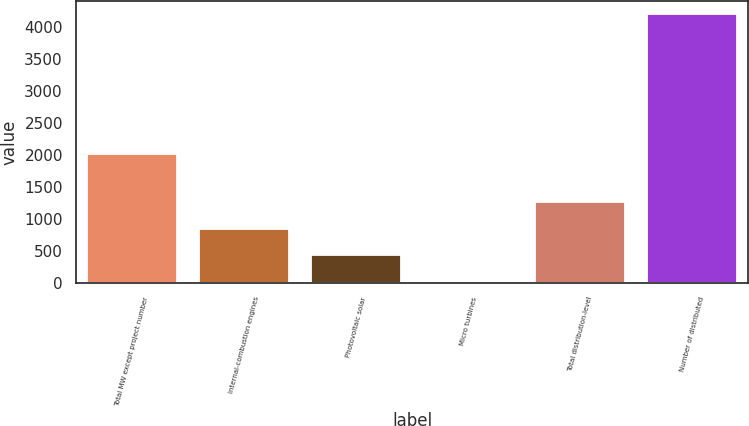Convert chart. <chart><loc_0><loc_0><loc_500><loc_500><bar_chart><fcel>Total MW except project number<fcel>Internal-combustion engines<fcel>Photovoltaic solar<fcel>Micro turbines<fcel>Total distribution-level<fcel>Number of distributed<nl><fcel>2014<fcel>847.2<fcel>428.1<fcel>9<fcel>1266.3<fcel>4200<nl></chart> 